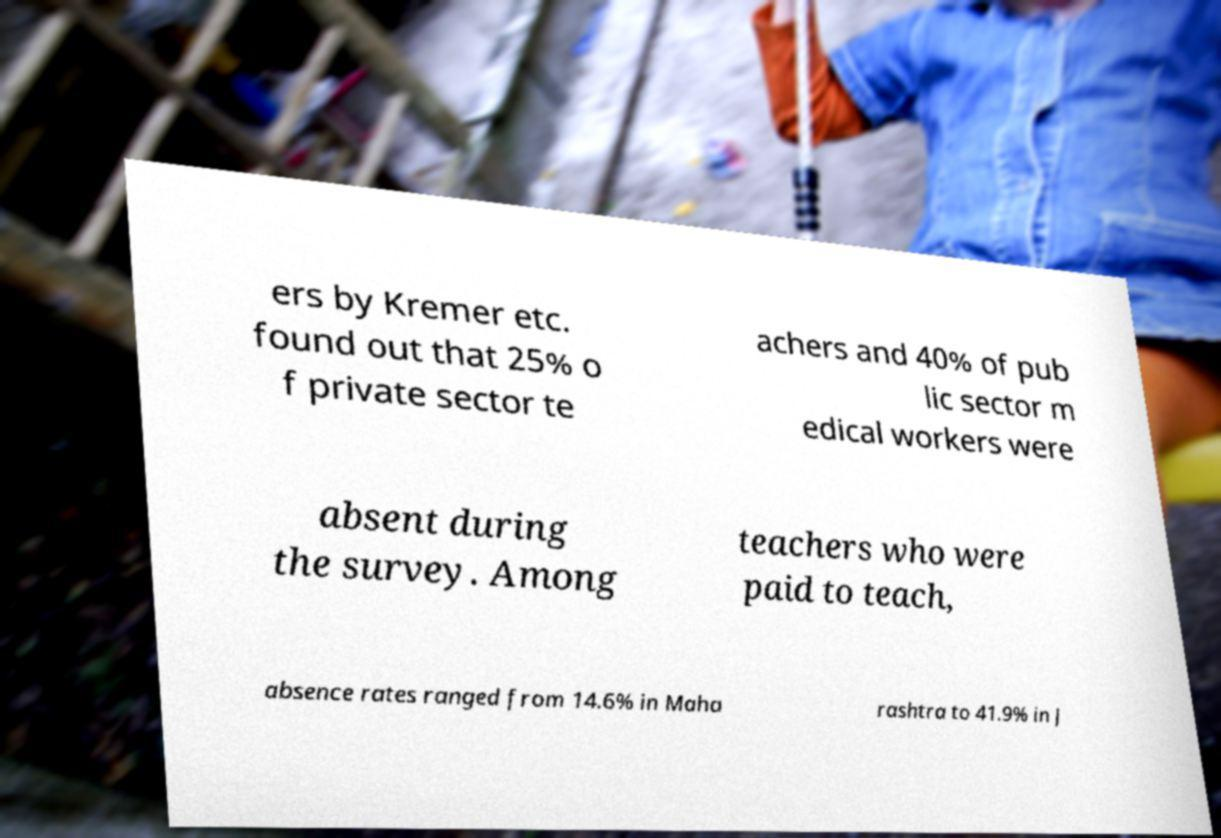Could you assist in decoding the text presented in this image and type it out clearly? ers by Kremer etc. found out that 25% o f private sector te achers and 40% of pub lic sector m edical workers were absent during the survey. Among teachers who were paid to teach, absence rates ranged from 14.6% in Maha rashtra to 41.9% in J 